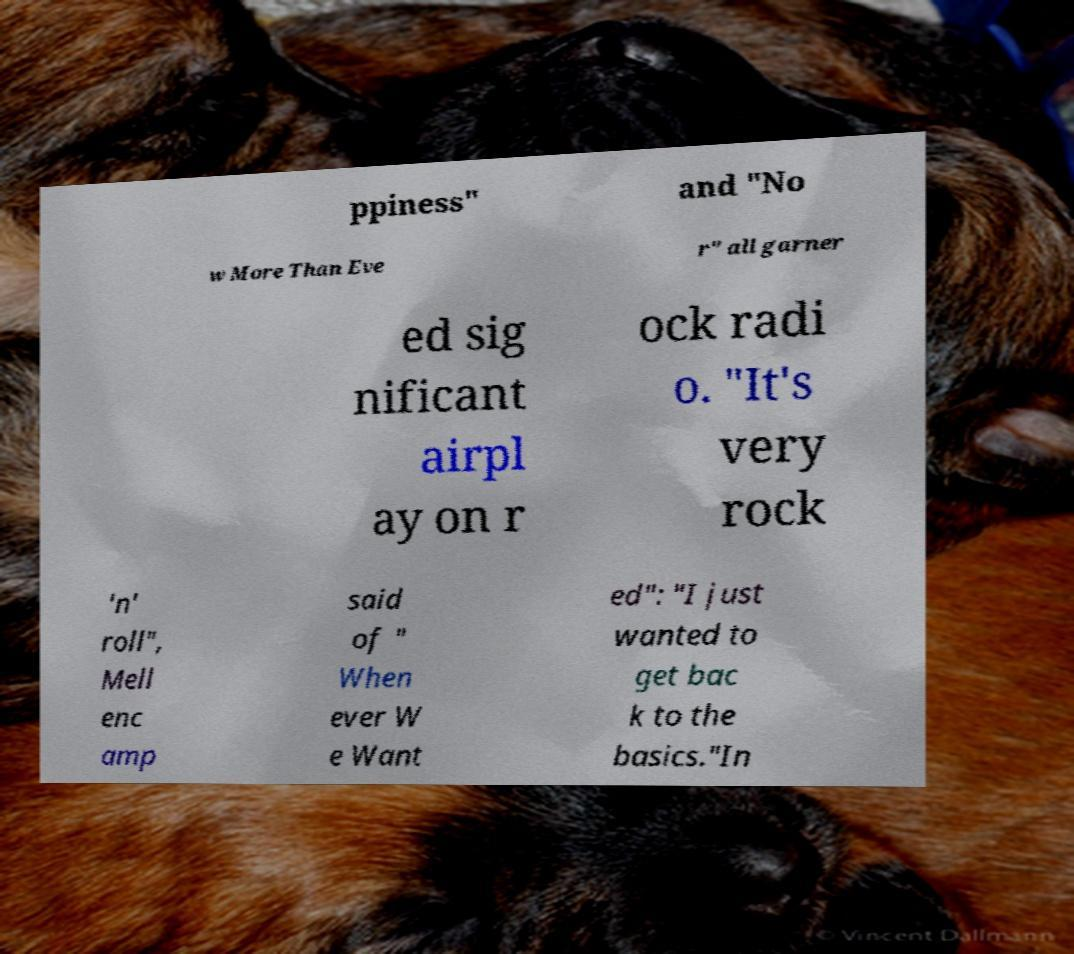Can you accurately transcribe the text from the provided image for me? ppiness" and "No w More Than Eve r" all garner ed sig nificant airpl ay on r ock radi o. "It's very rock 'n' roll", Mell enc amp said of " When ever W e Want ed": "I just wanted to get bac k to the basics."In 